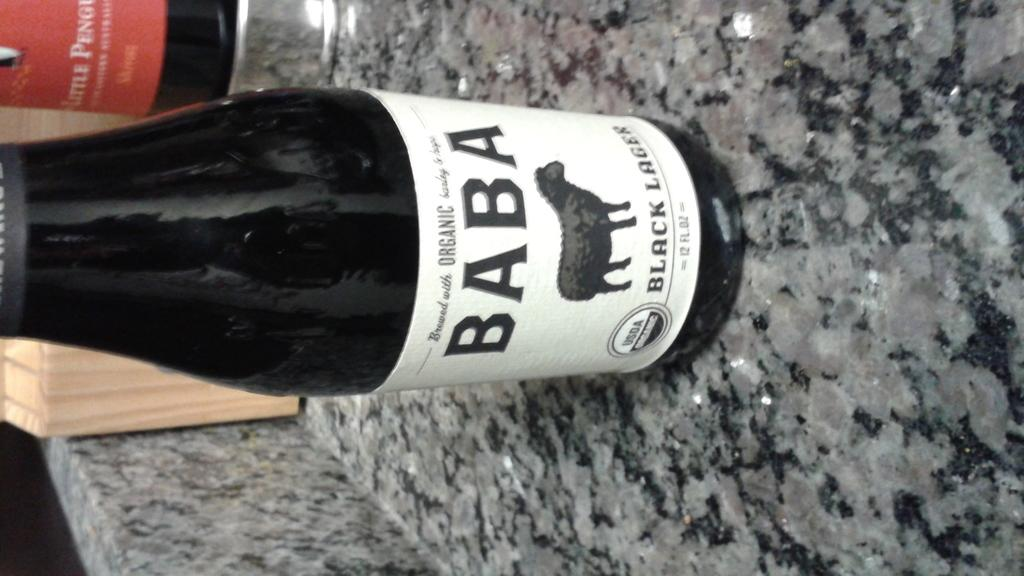<image>
Present a compact description of the photo's key features. A single bottle of Baba with a black sheep below the words on the bottles label. 